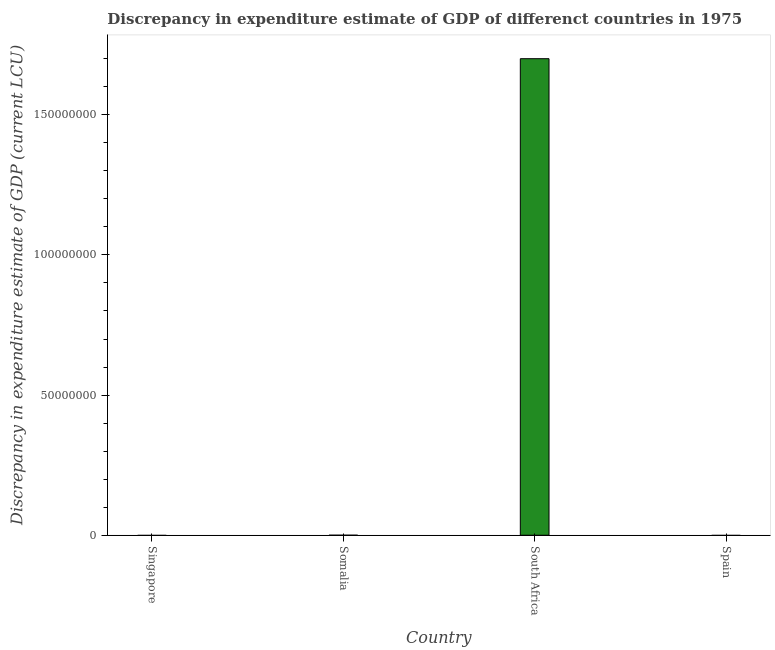Does the graph contain any zero values?
Ensure brevity in your answer.  Yes. What is the title of the graph?
Your answer should be compact. Discrepancy in expenditure estimate of GDP of differenct countries in 1975. What is the label or title of the Y-axis?
Offer a terse response. Discrepancy in expenditure estimate of GDP (current LCU). Across all countries, what is the maximum discrepancy in expenditure estimate of gdp?
Your response must be concise. 1.70e+08. In which country was the discrepancy in expenditure estimate of gdp maximum?
Your answer should be very brief. South Africa. What is the sum of the discrepancy in expenditure estimate of gdp?
Keep it short and to the point. 1.70e+08. What is the difference between the discrepancy in expenditure estimate of gdp in Somalia and South Africa?
Your answer should be very brief. -1.70e+08. What is the average discrepancy in expenditure estimate of gdp per country?
Ensure brevity in your answer.  4.25e+07. What is the median discrepancy in expenditure estimate of gdp?
Provide a succinct answer. 1216. In how many countries, is the discrepancy in expenditure estimate of gdp greater than 20000000 LCU?
Ensure brevity in your answer.  1. What is the ratio of the discrepancy in expenditure estimate of gdp in Somalia to that in South Africa?
Your answer should be compact. 0. Is the difference between the discrepancy in expenditure estimate of gdp in Somalia and South Africa greater than the difference between any two countries?
Provide a succinct answer. No. Is the sum of the discrepancy in expenditure estimate of gdp in Somalia and South Africa greater than the maximum discrepancy in expenditure estimate of gdp across all countries?
Offer a very short reply. Yes. What is the difference between the highest and the lowest discrepancy in expenditure estimate of gdp?
Provide a short and direct response. 1.70e+08. In how many countries, is the discrepancy in expenditure estimate of gdp greater than the average discrepancy in expenditure estimate of gdp taken over all countries?
Your answer should be compact. 1. How many bars are there?
Give a very brief answer. 2. How many countries are there in the graph?
Offer a terse response. 4. What is the Discrepancy in expenditure estimate of GDP (current LCU) in Singapore?
Offer a very short reply. 0. What is the Discrepancy in expenditure estimate of GDP (current LCU) of Somalia?
Offer a terse response. 2432. What is the Discrepancy in expenditure estimate of GDP (current LCU) in South Africa?
Offer a very short reply. 1.70e+08. What is the Discrepancy in expenditure estimate of GDP (current LCU) of Spain?
Your response must be concise. 0. What is the difference between the Discrepancy in expenditure estimate of GDP (current LCU) in Somalia and South Africa?
Provide a succinct answer. -1.70e+08. What is the ratio of the Discrepancy in expenditure estimate of GDP (current LCU) in Somalia to that in South Africa?
Ensure brevity in your answer.  0. 